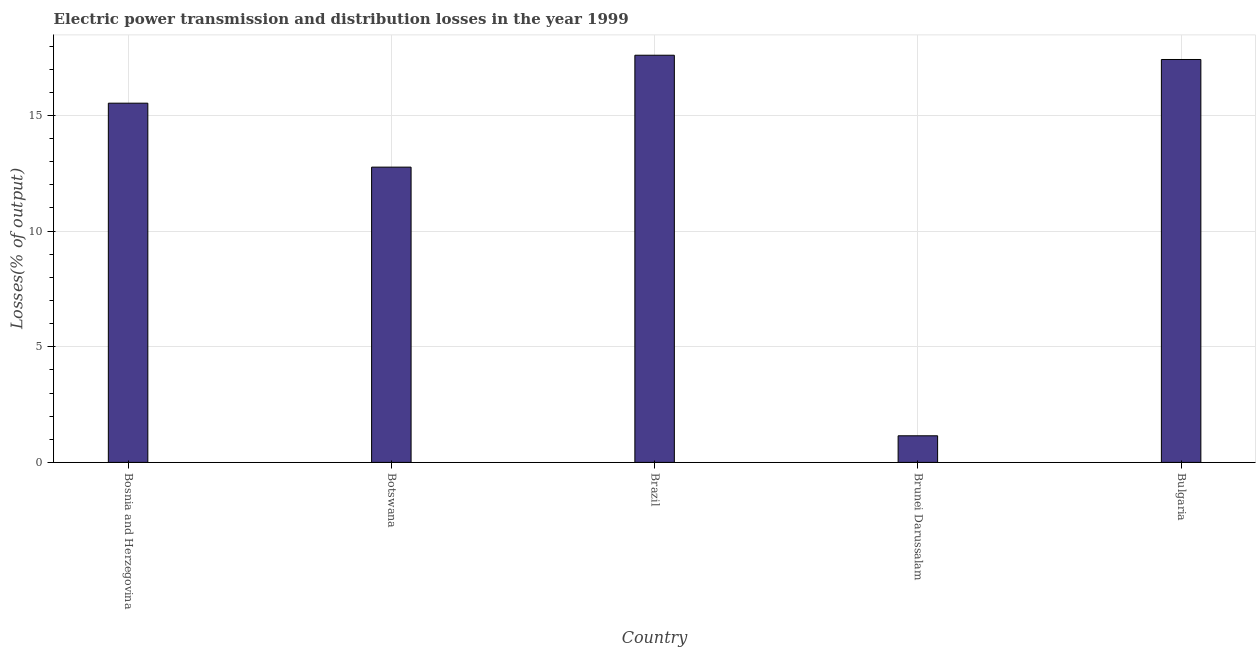What is the title of the graph?
Keep it short and to the point. Electric power transmission and distribution losses in the year 1999. What is the label or title of the X-axis?
Provide a short and direct response. Country. What is the label or title of the Y-axis?
Provide a succinct answer. Losses(% of output). What is the electric power transmission and distribution losses in Bosnia and Herzegovina?
Provide a short and direct response. 15.53. Across all countries, what is the maximum electric power transmission and distribution losses?
Provide a short and direct response. 17.6. Across all countries, what is the minimum electric power transmission and distribution losses?
Provide a short and direct response. 1.15. In which country was the electric power transmission and distribution losses maximum?
Your answer should be compact. Brazil. In which country was the electric power transmission and distribution losses minimum?
Offer a very short reply. Brunei Darussalam. What is the sum of the electric power transmission and distribution losses?
Ensure brevity in your answer.  64.47. What is the difference between the electric power transmission and distribution losses in Botswana and Bulgaria?
Provide a short and direct response. -4.65. What is the average electric power transmission and distribution losses per country?
Keep it short and to the point. 12.89. What is the median electric power transmission and distribution losses?
Offer a very short reply. 15.53. What is the ratio of the electric power transmission and distribution losses in Brazil to that in Brunei Darussalam?
Your response must be concise. 15.3. What is the difference between the highest and the second highest electric power transmission and distribution losses?
Keep it short and to the point. 0.18. What is the difference between the highest and the lowest electric power transmission and distribution losses?
Ensure brevity in your answer.  16.45. In how many countries, is the electric power transmission and distribution losses greater than the average electric power transmission and distribution losses taken over all countries?
Provide a succinct answer. 3. How many bars are there?
Make the answer very short. 5. Are all the bars in the graph horizontal?
Your answer should be compact. No. What is the difference between two consecutive major ticks on the Y-axis?
Your answer should be compact. 5. Are the values on the major ticks of Y-axis written in scientific E-notation?
Provide a short and direct response. No. What is the Losses(% of output) in Bosnia and Herzegovina?
Give a very brief answer. 15.53. What is the Losses(% of output) of Botswana?
Your response must be concise. 12.77. What is the Losses(% of output) of Brazil?
Ensure brevity in your answer.  17.6. What is the Losses(% of output) in Brunei Darussalam?
Offer a terse response. 1.15. What is the Losses(% of output) of Bulgaria?
Keep it short and to the point. 17.42. What is the difference between the Losses(% of output) in Bosnia and Herzegovina and Botswana?
Provide a succinct answer. 2.76. What is the difference between the Losses(% of output) in Bosnia and Herzegovina and Brazil?
Your answer should be compact. -2.07. What is the difference between the Losses(% of output) in Bosnia and Herzegovina and Brunei Darussalam?
Your answer should be compact. 14.38. What is the difference between the Losses(% of output) in Bosnia and Herzegovina and Bulgaria?
Give a very brief answer. -1.89. What is the difference between the Losses(% of output) in Botswana and Brazil?
Provide a succinct answer. -4.84. What is the difference between the Losses(% of output) in Botswana and Brunei Darussalam?
Make the answer very short. 11.62. What is the difference between the Losses(% of output) in Botswana and Bulgaria?
Make the answer very short. -4.65. What is the difference between the Losses(% of output) in Brazil and Brunei Darussalam?
Provide a succinct answer. 16.45. What is the difference between the Losses(% of output) in Brazil and Bulgaria?
Ensure brevity in your answer.  0.18. What is the difference between the Losses(% of output) in Brunei Darussalam and Bulgaria?
Your answer should be very brief. -16.27. What is the ratio of the Losses(% of output) in Bosnia and Herzegovina to that in Botswana?
Ensure brevity in your answer.  1.22. What is the ratio of the Losses(% of output) in Bosnia and Herzegovina to that in Brazil?
Offer a very short reply. 0.88. What is the ratio of the Losses(% of output) in Bosnia and Herzegovina to that in Brunei Darussalam?
Ensure brevity in your answer.  13.5. What is the ratio of the Losses(% of output) in Bosnia and Herzegovina to that in Bulgaria?
Keep it short and to the point. 0.89. What is the ratio of the Losses(% of output) in Botswana to that in Brazil?
Keep it short and to the point. 0.72. What is the ratio of the Losses(% of output) in Botswana to that in Brunei Darussalam?
Provide a short and direct response. 11.1. What is the ratio of the Losses(% of output) in Botswana to that in Bulgaria?
Provide a short and direct response. 0.73. What is the ratio of the Losses(% of output) in Brazil to that in Brunei Darussalam?
Provide a succinct answer. 15.3. What is the ratio of the Losses(% of output) in Brunei Darussalam to that in Bulgaria?
Provide a short and direct response. 0.07. 